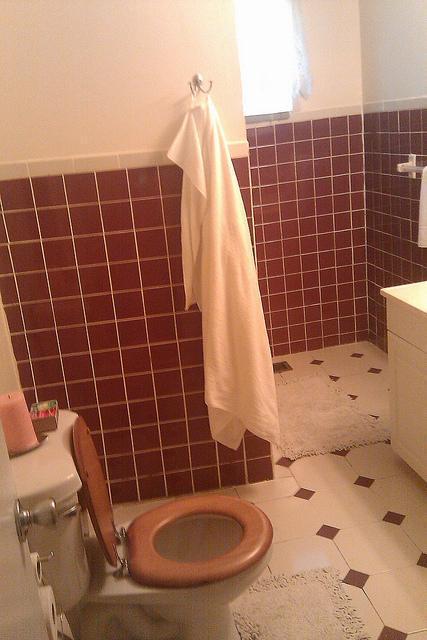How many toilets are in the bathroom?
Give a very brief answer. 1. 